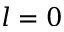<formula> <loc_0><loc_0><loc_500><loc_500>l = 0</formula> 